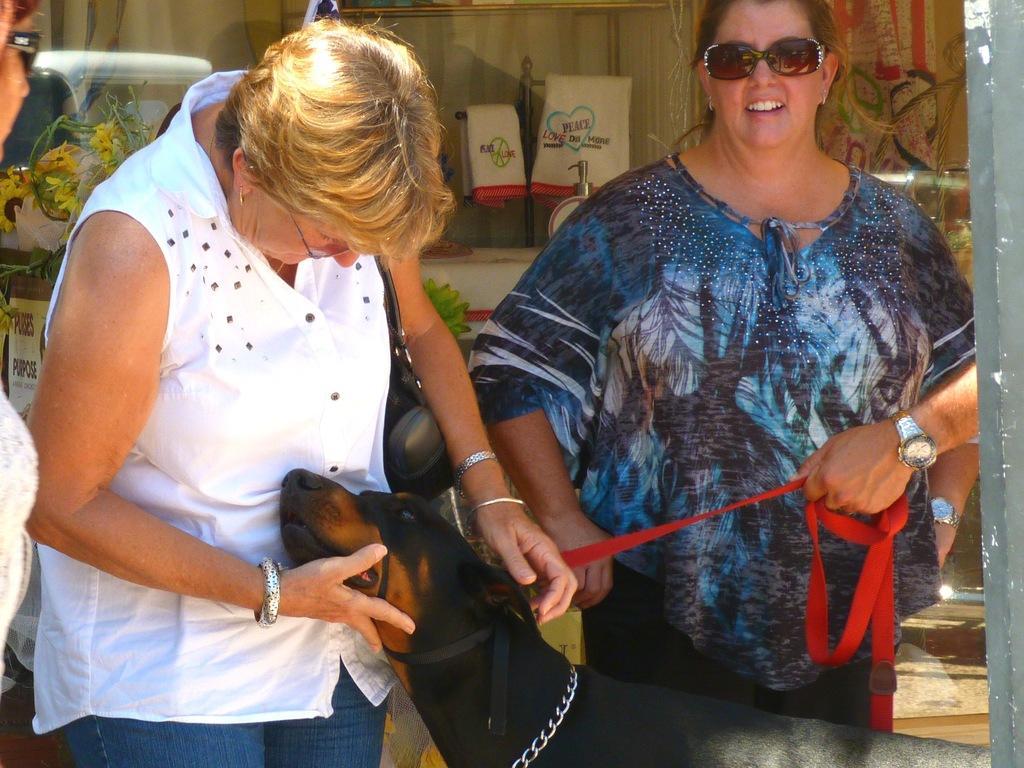Please provide a concise description of this image. In this image there are two women standing and there is a dog. 